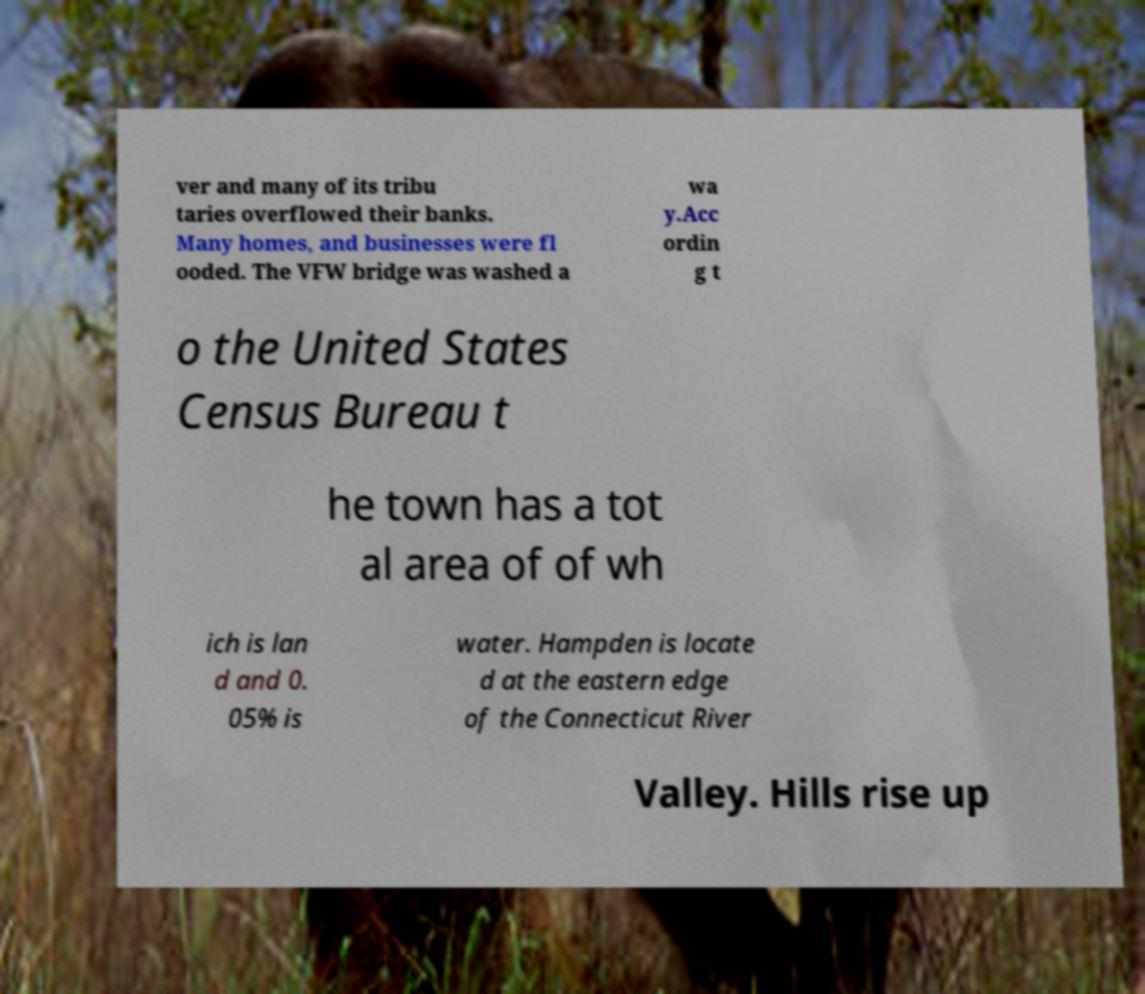Can you read and provide the text displayed in the image?This photo seems to have some interesting text. Can you extract and type it out for me? ver and many of its tribu taries overflowed their banks. Many homes, and businesses were fl ooded. The VFW bridge was washed a wa y.Acc ordin g t o the United States Census Bureau t he town has a tot al area of of wh ich is lan d and 0. 05% is water. Hampden is locate d at the eastern edge of the Connecticut River Valley. Hills rise up 